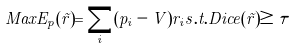<formula> <loc_0><loc_0><loc_500><loc_500>M a x E _ { p } ( \vec { r } ) = \sum _ { i } ( p _ { i } - V ) r _ { i } s . t . D i c e ( \vec { r } ) \geq \tau</formula> 